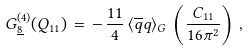Convert formula to latex. <formula><loc_0><loc_0><loc_500><loc_500>G _ { \underline { 8 } } ^ { ( 4 ) } ( Q _ { 1 1 } ) \, = \, - \, \frac { 1 1 } { 4 } \, \langle \overline { q } q \rangle _ { G } \, \left ( \frac { C _ { 1 1 } } { 1 6 \pi ^ { 2 } } \right ) \, ,</formula> 